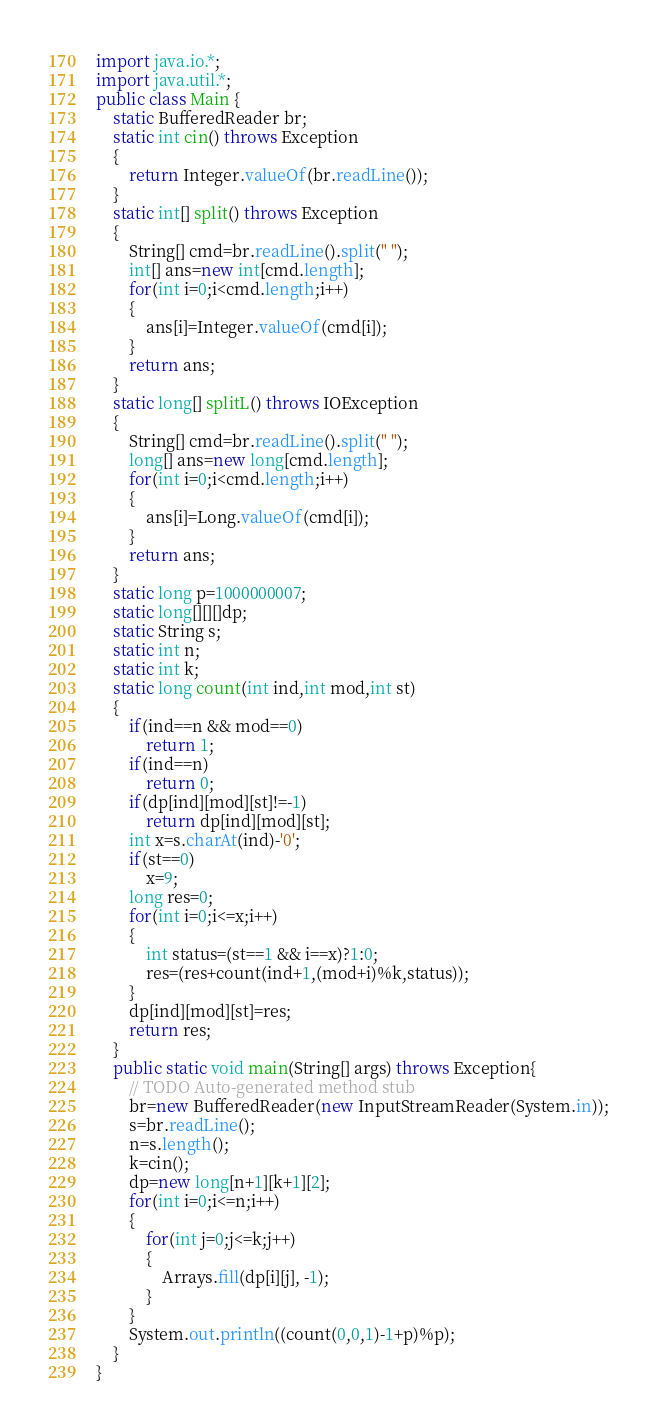<code> <loc_0><loc_0><loc_500><loc_500><_Java_>
import java.io.*;
import java.util.*;
public class Main {
	static BufferedReader br;
	static int cin() throws Exception
	{
		return Integer.valueOf(br.readLine());
	}
	static int[] split() throws Exception
	{
		String[] cmd=br.readLine().split(" ");
		int[] ans=new int[cmd.length];
		for(int i=0;i<cmd.length;i++)
		{
			ans[i]=Integer.valueOf(cmd[i]);
		}
		return ans;
	}
	static long[] splitL() throws IOException
	{
		String[] cmd=br.readLine().split(" ");
		long[] ans=new long[cmd.length];
		for(int i=0;i<cmd.length;i++)
		{
			ans[i]=Long.valueOf(cmd[i]);
		}
		return ans;
	}
	static long p=1000000007;
	static long[][][]dp;
	static String s;
	static int n;
	static int k;
	static long count(int ind,int mod,int st)
	{
		if(ind==n && mod==0)
			return 1;
		if(ind==n)
			return 0;
		if(dp[ind][mod][st]!=-1)
			return dp[ind][mod][st];
		int x=s.charAt(ind)-'0';
		if(st==0)
			x=9;
		long res=0;
		for(int i=0;i<=x;i++)
		{
			int status=(st==1 && i==x)?1:0;
			res=(res+count(ind+1,(mod+i)%k,status));
		}
		dp[ind][mod][st]=res;
		return res;
	}
	public static void main(String[] args) throws Exception{
		// TODO Auto-generated method stub
		br=new BufferedReader(new InputStreamReader(System.in));
		s=br.readLine();
		n=s.length();
		k=cin();
		dp=new long[n+1][k+1][2];
		for(int i=0;i<=n;i++)
		{
			for(int j=0;j<=k;j++)
			{
				Arrays.fill(dp[i][j], -1);
			}
		}
		System.out.println((count(0,0,1)-1+p)%p);
	}
}
</code> 